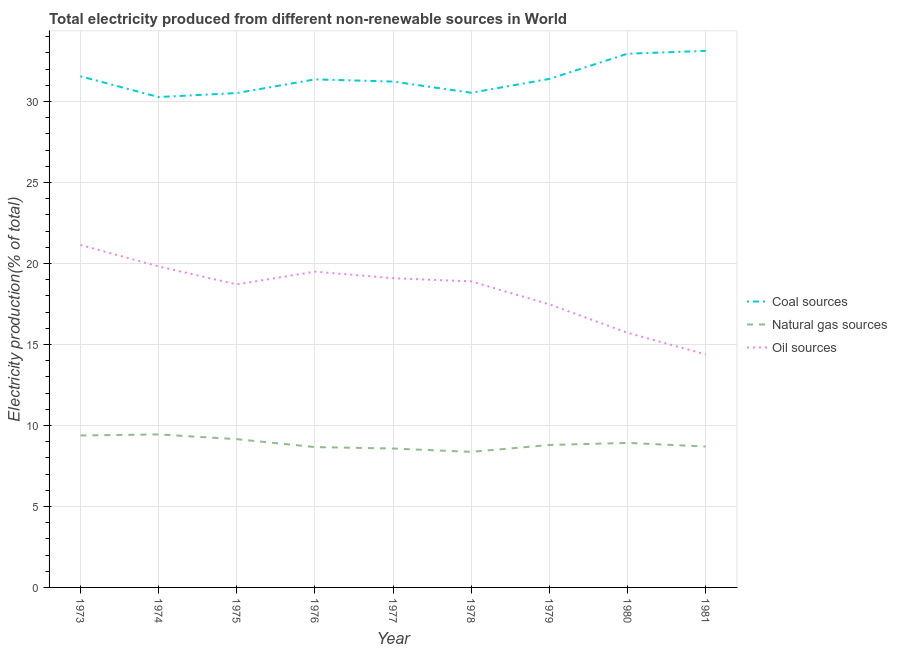How many different coloured lines are there?
Give a very brief answer. 3. Is the number of lines equal to the number of legend labels?
Offer a very short reply. Yes. What is the percentage of electricity produced by natural gas in 1980?
Provide a succinct answer. 8.92. Across all years, what is the maximum percentage of electricity produced by coal?
Give a very brief answer. 33.12. Across all years, what is the minimum percentage of electricity produced by natural gas?
Give a very brief answer. 8.37. In which year was the percentage of electricity produced by natural gas maximum?
Ensure brevity in your answer.  1974. In which year was the percentage of electricity produced by natural gas minimum?
Your answer should be compact. 1978. What is the total percentage of electricity produced by coal in the graph?
Offer a very short reply. 282.95. What is the difference between the percentage of electricity produced by oil sources in 1974 and that in 1978?
Offer a very short reply. 0.92. What is the difference between the percentage of electricity produced by coal in 1981 and the percentage of electricity produced by oil sources in 1979?
Provide a succinct answer. 15.65. What is the average percentage of electricity produced by oil sources per year?
Make the answer very short. 18.3. In the year 1980, what is the difference between the percentage of electricity produced by oil sources and percentage of electricity produced by coal?
Provide a succinct answer. -17.23. In how many years, is the percentage of electricity produced by coal greater than 30 %?
Provide a succinct answer. 9. What is the ratio of the percentage of electricity produced by coal in 1975 to that in 1977?
Your response must be concise. 0.98. Is the difference between the percentage of electricity produced by oil sources in 1979 and 1981 greater than the difference between the percentage of electricity produced by coal in 1979 and 1981?
Offer a terse response. Yes. What is the difference between the highest and the second highest percentage of electricity produced by oil sources?
Offer a very short reply. 1.33. What is the difference between the highest and the lowest percentage of electricity produced by natural gas?
Keep it short and to the point. 1.08. Does the percentage of electricity produced by natural gas monotonically increase over the years?
Provide a succinct answer. No. Is the percentage of electricity produced by coal strictly greater than the percentage of electricity produced by oil sources over the years?
Give a very brief answer. Yes. How many lines are there?
Offer a very short reply. 3. How many years are there in the graph?
Make the answer very short. 9. Are the values on the major ticks of Y-axis written in scientific E-notation?
Give a very brief answer. No. Where does the legend appear in the graph?
Offer a terse response. Center right. What is the title of the graph?
Give a very brief answer. Total electricity produced from different non-renewable sources in World. What is the label or title of the Y-axis?
Offer a terse response. Electricity production(% of total). What is the Electricity production(% of total) of Coal sources in 1973?
Make the answer very short. 31.56. What is the Electricity production(% of total) of Natural gas sources in 1973?
Make the answer very short. 9.38. What is the Electricity production(% of total) of Oil sources in 1973?
Make the answer very short. 21.15. What is the Electricity production(% of total) of Coal sources in 1974?
Give a very brief answer. 30.27. What is the Electricity production(% of total) of Natural gas sources in 1974?
Your response must be concise. 9.45. What is the Electricity production(% of total) of Oil sources in 1974?
Provide a succinct answer. 19.82. What is the Electricity production(% of total) in Coal sources in 1975?
Provide a short and direct response. 30.52. What is the Electricity production(% of total) of Natural gas sources in 1975?
Keep it short and to the point. 9.15. What is the Electricity production(% of total) of Oil sources in 1975?
Offer a terse response. 18.71. What is the Electricity production(% of total) of Coal sources in 1976?
Keep it short and to the point. 31.36. What is the Electricity production(% of total) in Natural gas sources in 1976?
Provide a succinct answer. 8.66. What is the Electricity production(% of total) of Oil sources in 1976?
Keep it short and to the point. 19.5. What is the Electricity production(% of total) of Coal sources in 1977?
Keep it short and to the point. 31.23. What is the Electricity production(% of total) of Natural gas sources in 1977?
Your response must be concise. 8.58. What is the Electricity production(% of total) in Oil sources in 1977?
Offer a very short reply. 19.09. What is the Electricity production(% of total) in Coal sources in 1978?
Your response must be concise. 30.54. What is the Electricity production(% of total) of Natural gas sources in 1978?
Offer a very short reply. 8.37. What is the Electricity production(% of total) in Oil sources in 1978?
Provide a succinct answer. 18.89. What is the Electricity production(% of total) of Coal sources in 1979?
Your answer should be compact. 31.39. What is the Electricity production(% of total) in Natural gas sources in 1979?
Provide a succinct answer. 8.79. What is the Electricity production(% of total) in Oil sources in 1979?
Offer a very short reply. 17.48. What is the Electricity production(% of total) in Coal sources in 1980?
Ensure brevity in your answer.  32.95. What is the Electricity production(% of total) of Natural gas sources in 1980?
Your response must be concise. 8.92. What is the Electricity production(% of total) of Oil sources in 1980?
Keep it short and to the point. 15.72. What is the Electricity production(% of total) in Coal sources in 1981?
Give a very brief answer. 33.12. What is the Electricity production(% of total) of Natural gas sources in 1981?
Provide a short and direct response. 8.7. What is the Electricity production(% of total) in Oil sources in 1981?
Provide a short and direct response. 14.39. Across all years, what is the maximum Electricity production(% of total) of Coal sources?
Offer a very short reply. 33.12. Across all years, what is the maximum Electricity production(% of total) in Natural gas sources?
Ensure brevity in your answer.  9.45. Across all years, what is the maximum Electricity production(% of total) of Oil sources?
Offer a very short reply. 21.15. Across all years, what is the minimum Electricity production(% of total) in Coal sources?
Keep it short and to the point. 30.27. Across all years, what is the minimum Electricity production(% of total) of Natural gas sources?
Give a very brief answer. 8.37. Across all years, what is the minimum Electricity production(% of total) in Oil sources?
Your answer should be very brief. 14.39. What is the total Electricity production(% of total) of Coal sources in the graph?
Provide a short and direct response. 282.95. What is the total Electricity production(% of total) of Natural gas sources in the graph?
Provide a short and direct response. 80. What is the total Electricity production(% of total) of Oil sources in the graph?
Provide a short and direct response. 164.73. What is the difference between the Electricity production(% of total) of Coal sources in 1973 and that in 1974?
Ensure brevity in your answer.  1.28. What is the difference between the Electricity production(% of total) in Natural gas sources in 1973 and that in 1974?
Offer a very short reply. -0.07. What is the difference between the Electricity production(% of total) of Oil sources in 1973 and that in 1974?
Keep it short and to the point. 1.33. What is the difference between the Electricity production(% of total) of Coal sources in 1973 and that in 1975?
Keep it short and to the point. 1.04. What is the difference between the Electricity production(% of total) in Natural gas sources in 1973 and that in 1975?
Offer a very short reply. 0.23. What is the difference between the Electricity production(% of total) of Oil sources in 1973 and that in 1975?
Your response must be concise. 2.44. What is the difference between the Electricity production(% of total) of Coal sources in 1973 and that in 1976?
Provide a short and direct response. 0.19. What is the difference between the Electricity production(% of total) in Natural gas sources in 1973 and that in 1976?
Offer a very short reply. 0.72. What is the difference between the Electricity production(% of total) in Oil sources in 1973 and that in 1976?
Your answer should be compact. 1.65. What is the difference between the Electricity production(% of total) of Coal sources in 1973 and that in 1977?
Your response must be concise. 0.32. What is the difference between the Electricity production(% of total) of Natural gas sources in 1973 and that in 1977?
Keep it short and to the point. 0.81. What is the difference between the Electricity production(% of total) in Oil sources in 1973 and that in 1977?
Offer a very short reply. 2.05. What is the difference between the Electricity production(% of total) of Coal sources in 1973 and that in 1978?
Provide a short and direct response. 1.02. What is the difference between the Electricity production(% of total) in Natural gas sources in 1973 and that in 1978?
Keep it short and to the point. 1.01. What is the difference between the Electricity production(% of total) of Oil sources in 1973 and that in 1978?
Provide a short and direct response. 2.25. What is the difference between the Electricity production(% of total) in Coal sources in 1973 and that in 1979?
Keep it short and to the point. 0.16. What is the difference between the Electricity production(% of total) of Natural gas sources in 1973 and that in 1979?
Your response must be concise. 0.59. What is the difference between the Electricity production(% of total) of Oil sources in 1973 and that in 1979?
Give a very brief answer. 3.67. What is the difference between the Electricity production(% of total) in Coal sources in 1973 and that in 1980?
Give a very brief answer. -1.39. What is the difference between the Electricity production(% of total) in Natural gas sources in 1973 and that in 1980?
Provide a succinct answer. 0.46. What is the difference between the Electricity production(% of total) in Oil sources in 1973 and that in 1980?
Make the answer very short. 5.42. What is the difference between the Electricity production(% of total) of Coal sources in 1973 and that in 1981?
Keep it short and to the point. -1.57. What is the difference between the Electricity production(% of total) in Natural gas sources in 1973 and that in 1981?
Your answer should be very brief. 0.68. What is the difference between the Electricity production(% of total) of Oil sources in 1973 and that in 1981?
Provide a succinct answer. 6.76. What is the difference between the Electricity production(% of total) of Coal sources in 1974 and that in 1975?
Make the answer very short. -0.25. What is the difference between the Electricity production(% of total) in Natural gas sources in 1974 and that in 1975?
Offer a very short reply. 0.29. What is the difference between the Electricity production(% of total) in Oil sources in 1974 and that in 1975?
Make the answer very short. 1.11. What is the difference between the Electricity production(% of total) of Coal sources in 1974 and that in 1976?
Keep it short and to the point. -1.09. What is the difference between the Electricity production(% of total) of Natural gas sources in 1974 and that in 1976?
Give a very brief answer. 0.78. What is the difference between the Electricity production(% of total) in Oil sources in 1974 and that in 1976?
Ensure brevity in your answer.  0.32. What is the difference between the Electricity production(% of total) in Coal sources in 1974 and that in 1977?
Offer a terse response. -0.96. What is the difference between the Electricity production(% of total) of Natural gas sources in 1974 and that in 1977?
Provide a succinct answer. 0.87. What is the difference between the Electricity production(% of total) in Oil sources in 1974 and that in 1977?
Offer a terse response. 0.73. What is the difference between the Electricity production(% of total) in Coal sources in 1974 and that in 1978?
Offer a terse response. -0.26. What is the difference between the Electricity production(% of total) of Natural gas sources in 1974 and that in 1978?
Your answer should be compact. 1.08. What is the difference between the Electricity production(% of total) in Oil sources in 1974 and that in 1978?
Keep it short and to the point. 0.92. What is the difference between the Electricity production(% of total) in Coal sources in 1974 and that in 1979?
Provide a short and direct response. -1.12. What is the difference between the Electricity production(% of total) of Natural gas sources in 1974 and that in 1979?
Your answer should be compact. 0.65. What is the difference between the Electricity production(% of total) in Oil sources in 1974 and that in 1979?
Provide a short and direct response. 2.34. What is the difference between the Electricity production(% of total) of Coal sources in 1974 and that in 1980?
Provide a succinct answer. -2.68. What is the difference between the Electricity production(% of total) in Natural gas sources in 1974 and that in 1980?
Your answer should be compact. 0.52. What is the difference between the Electricity production(% of total) in Oil sources in 1974 and that in 1980?
Provide a short and direct response. 4.1. What is the difference between the Electricity production(% of total) in Coal sources in 1974 and that in 1981?
Provide a succinct answer. -2.85. What is the difference between the Electricity production(% of total) of Natural gas sources in 1974 and that in 1981?
Your response must be concise. 0.75. What is the difference between the Electricity production(% of total) of Oil sources in 1974 and that in 1981?
Keep it short and to the point. 5.43. What is the difference between the Electricity production(% of total) in Coal sources in 1975 and that in 1976?
Offer a terse response. -0.84. What is the difference between the Electricity production(% of total) in Natural gas sources in 1975 and that in 1976?
Offer a terse response. 0.49. What is the difference between the Electricity production(% of total) of Oil sources in 1975 and that in 1976?
Ensure brevity in your answer.  -0.79. What is the difference between the Electricity production(% of total) in Coal sources in 1975 and that in 1977?
Your answer should be compact. -0.71. What is the difference between the Electricity production(% of total) of Natural gas sources in 1975 and that in 1977?
Keep it short and to the point. 0.58. What is the difference between the Electricity production(% of total) in Oil sources in 1975 and that in 1977?
Keep it short and to the point. -0.39. What is the difference between the Electricity production(% of total) of Coal sources in 1975 and that in 1978?
Ensure brevity in your answer.  -0.02. What is the difference between the Electricity production(% of total) in Natural gas sources in 1975 and that in 1978?
Your response must be concise. 0.78. What is the difference between the Electricity production(% of total) of Oil sources in 1975 and that in 1978?
Give a very brief answer. -0.19. What is the difference between the Electricity production(% of total) in Coal sources in 1975 and that in 1979?
Give a very brief answer. -0.87. What is the difference between the Electricity production(% of total) of Natural gas sources in 1975 and that in 1979?
Keep it short and to the point. 0.36. What is the difference between the Electricity production(% of total) of Oil sources in 1975 and that in 1979?
Provide a succinct answer. 1.23. What is the difference between the Electricity production(% of total) in Coal sources in 1975 and that in 1980?
Keep it short and to the point. -2.43. What is the difference between the Electricity production(% of total) in Natural gas sources in 1975 and that in 1980?
Provide a short and direct response. 0.23. What is the difference between the Electricity production(% of total) of Oil sources in 1975 and that in 1980?
Keep it short and to the point. 2.98. What is the difference between the Electricity production(% of total) in Coal sources in 1975 and that in 1981?
Make the answer very short. -2.6. What is the difference between the Electricity production(% of total) of Natural gas sources in 1975 and that in 1981?
Ensure brevity in your answer.  0.46. What is the difference between the Electricity production(% of total) of Oil sources in 1975 and that in 1981?
Your answer should be compact. 4.32. What is the difference between the Electricity production(% of total) in Coal sources in 1976 and that in 1977?
Ensure brevity in your answer.  0.13. What is the difference between the Electricity production(% of total) in Natural gas sources in 1976 and that in 1977?
Keep it short and to the point. 0.09. What is the difference between the Electricity production(% of total) of Oil sources in 1976 and that in 1977?
Make the answer very short. 0.4. What is the difference between the Electricity production(% of total) in Coal sources in 1976 and that in 1978?
Offer a very short reply. 0.83. What is the difference between the Electricity production(% of total) of Natural gas sources in 1976 and that in 1978?
Offer a very short reply. 0.3. What is the difference between the Electricity production(% of total) of Oil sources in 1976 and that in 1978?
Offer a very short reply. 0.6. What is the difference between the Electricity production(% of total) of Coal sources in 1976 and that in 1979?
Your answer should be very brief. -0.03. What is the difference between the Electricity production(% of total) of Natural gas sources in 1976 and that in 1979?
Provide a succinct answer. -0.13. What is the difference between the Electricity production(% of total) of Oil sources in 1976 and that in 1979?
Your answer should be compact. 2.02. What is the difference between the Electricity production(% of total) of Coal sources in 1976 and that in 1980?
Keep it short and to the point. -1.59. What is the difference between the Electricity production(% of total) in Natural gas sources in 1976 and that in 1980?
Keep it short and to the point. -0.26. What is the difference between the Electricity production(% of total) of Oil sources in 1976 and that in 1980?
Keep it short and to the point. 3.77. What is the difference between the Electricity production(% of total) of Coal sources in 1976 and that in 1981?
Make the answer very short. -1.76. What is the difference between the Electricity production(% of total) in Natural gas sources in 1976 and that in 1981?
Your answer should be very brief. -0.03. What is the difference between the Electricity production(% of total) of Oil sources in 1976 and that in 1981?
Ensure brevity in your answer.  5.11. What is the difference between the Electricity production(% of total) in Coal sources in 1977 and that in 1978?
Give a very brief answer. 0.69. What is the difference between the Electricity production(% of total) of Natural gas sources in 1977 and that in 1978?
Offer a terse response. 0.21. What is the difference between the Electricity production(% of total) in Oil sources in 1977 and that in 1978?
Provide a succinct answer. 0.2. What is the difference between the Electricity production(% of total) in Coal sources in 1977 and that in 1979?
Your response must be concise. -0.16. What is the difference between the Electricity production(% of total) in Natural gas sources in 1977 and that in 1979?
Provide a short and direct response. -0.22. What is the difference between the Electricity production(% of total) of Oil sources in 1977 and that in 1979?
Your answer should be very brief. 1.61. What is the difference between the Electricity production(% of total) of Coal sources in 1977 and that in 1980?
Offer a terse response. -1.72. What is the difference between the Electricity production(% of total) of Natural gas sources in 1977 and that in 1980?
Provide a short and direct response. -0.35. What is the difference between the Electricity production(% of total) in Oil sources in 1977 and that in 1980?
Keep it short and to the point. 3.37. What is the difference between the Electricity production(% of total) of Coal sources in 1977 and that in 1981?
Offer a terse response. -1.89. What is the difference between the Electricity production(% of total) in Natural gas sources in 1977 and that in 1981?
Keep it short and to the point. -0.12. What is the difference between the Electricity production(% of total) of Oil sources in 1977 and that in 1981?
Offer a terse response. 4.7. What is the difference between the Electricity production(% of total) in Coal sources in 1978 and that in 1979?
Ensure brevity in your answer.  -0.86. What is the difference between the Electricity production(% of total) of Natural gas sources in 1978 and that in 1979?
Provide a succinct answer. -0.42. What is the difference between the Electricity production(% of total) of Oil sources in 1978 and that in 1979?
Ensure brevity in your answer.  1.42. What is the difference between the Electricity production(% of total) of Coal sources in 1978 and that in 1980?
Your response must be concise. -2.41. What is the difference between the Electricity production(% of total) in Natural gas sources in 1978 and that in 1980?
Provide a short and direct response. -0.55. What is the difference between the Electricity production(% of total) of Oil sources in 1978 and that in 1980?
Give a very brief answer. 3.17. What is the difference between the Electricity production(% of total) in Coal sources in 1978 and that in 1981?
Your answer should be compact. -2.59. What is the difference between the Electricity production(% of total) of Natural gas sources in 1978 and that in 1981?
Ensure brevity in your answer.  -0.33. What is the difference between the Electricity production(% of total) of Oil sources in 1978 and that in 1981?
Provide a succinct answer. 4.51. What is the difference between the Electricity production(% of total) of Coal sources in 1979 and that in 1980?
Give a very brief answer. -1.56. What is the difference between the Electricity production(% of total) of Natural gas sources in 1979 and that in 1980?
Your response must be concise. -0.13. What is the difference between the Electricity production(% of total) in Oil sources in 1979 and that in 1980?
Offer a very short reply. 1.76. What is the difference between the Electricity production(% of total) of Coal sources in 1979 and that in 1981?
Provide a short and direct response. -1.73. What is the difference between the Electricity production(% of total) in Natural gas sources in 1979 and that in 1981?
Provide a succinct answer. 0.1. What is the difference between the Electricity production(% of total) in Oil sources in 1979 and that in 1981?
Your response must be concise. 3.09. What is the difference between the Electricity production(% of total) of Coal sources in 1980 and that in 1981?
Provide a succinct answer. -0.17. What is the difference between the Electricity production(% of total) in Natural gas sources in 1980 and that in 1981?
Give a very brief answer. 0.22. What is the difference between the Electricity production(% of total) of Oil sources in 1980 and that in 1981?
Give a very brief answer. 1.33. What is the difference between the Electricity production(% of total) in Coal sources in 1973 and the Electricity production(% of total) in Natural gas sources in 1974?
Make the answer very short. 22.11. What is the difference between the Electricity production(% of total) in Coal sources in 1973 and the Electricity production(% of total) in Oil sources in 1974?
Your answer should be compact. 11.74. What is the difference between the Electricity production(% of total) of Natural gas sources in 1973 and the Electricity production(% of total) of Oil sources in 1974?
Offer a terse response. -10.44. What is the difference between the Electricity production(% of total) in Coal sources in 1973 and the Electricity production(% of total) in Natural gas sources in 1975?
Your answer should be very brief. 22.4. What is the difference between the Electricity production(% of total) of Coal sources in 1973 and the Electricity production(% of total) of Oil sources in 1975?
Ensure brevity in your answer.  12.85. What is the difference between the Electricity production(% of total) in Natural gas sources in 1973 and the Electricity production(% of total) in Oil sources in 1975?
Give a very brief answer. -9.32. What is the difference between the Electricity production(% of total) in Coal sources in 1973 and the Electricity production(% of total) in Natural gas sources in 1976?
Your answer should be compact. 22.89. What is the difference between the Electricity production(% of total) of Coal sources in 1973 and the Electricity production(% of total) of Oil sources in 1976?
Offer a very short reply. 12.06. What is the difference between the Electricity production(% of total) of Natural gas sources in 1973 and the Electricity production(% of total) of Oil sources in 1976?
Your answer should be compact. -10.11. What is the difference between the Electricity production(% of total) in Coal sources in 1973 and the Electricity production(% of total) in Natural gas sources in 1977?
Keep it short and to the point. 22.98. What is the difference between the Electricity production(% of total) of Coal sources in 1973 and the Electricity production(% of total) of Oil sources in 1977?
Ensure brevity in your answer.  12.46. What is the difference between the Electricity production(% of total) in Natural gas sources in 1973 and the Electricity production(% of total) in Oil sources in 1977?
Give a very brief answer. -9.71. What is the difference between the Electricity production(% of total) of Coal sources in 1973 and the Electricity production(% of total) of Natural gas sources in 1978?
Provide a short and direct response. 23.19. What is the difference between the Electricity production(% of total) of Coal sources in 1973 and the Electricity production(% of total) of Oil sources in 1978?
Provide a short and direct response. 12.66. What is the difference between the Electricity production(% of total) in Natural gas sources in 1973 and the Electricity production(% of total) in Oil sources in 1978?
Offer a terse response. -9.51. What is the difference between the Electricity production(% of total) of Coal sources in 1973 and the Electricity production(% of total) of Natural gas sources in 1979?
Keep it short and to the point. 22.76. What is the difference between the Electricity production(% of total) of Coal sources in 1973 and the Electricity production(% of total) of Oil sources in 1979?
Your answer should be very brief. 14.08. What is the difference between the Electricity production(% of total) in Natural gas sources in 1973 and the Electricity production(% of total) in Oil sources in 1979?
Provide a short and direct response. -8.1. What is the difference between the Electricity production(% of total) of Coal sources in 1973 and the Electricity production(% of total) of Natural gas sources in 1980?
Provide a succinct answer. 22.63. What is the difference between the Electricity production(% of total) in Coal sources in 1973 and the Electricity production(% of total) in Oil sources in 1980?
Give a very brief answer. 15.83. What is the difference between the Electricity production(% of total) of Natural gas sources in 1973 and the Electricity production(% of total) of Oil sources in 1980?
Provide a short and direct response. -6.34. What is the difference between the Electricity production(% of total) in Coal sources in 1973 and the Electricity production(% of total) in Natural gas sources in 1981?
Make the answer very short. 22.86. What is the difference between the Electricity production(% of total) of Coal sources in 1973 and the Electricity production(% of total) of Oil sources in 1981?
Give a very brief answer. 17.17. What is the difference between the Electricity production(% of total) in Natural gas sources in 1973 and the Electricity production(% of total) in Oil sources in 1981?
Make the answer very short. -5.01. What is the difference between the Electricity production(% of total) of Coal sources in 1974 and the Electricity production(% of total) of Natural gas sources in 1975?
Ensure brevity in your answer.  21.12. What is the difference between the Electricity production(% of total) in Coal sources in 1974 and the Electricity production(% of total) in Oil sources in 1975?
Provide a succinct answer. 11.57. What is the difference between the Electricity production(% of total) in Natural gas sources in 1974 and the Electricity production(% of total) in Oil sources in 1975?
Provide a succinct answer. -9.26. What is the difference between the Electricity production(% of total) of Coal sources in 1974 and the Electricity production(% of total) of Natural gas sources in 1976?
Your answer should be compact. 21.61. What is the difference between the Electricity production(% of total) of Coal sources in 1974 and the Electricity production(% of total) of Oil sources in 1976?
Keep it short and to the point. 10.78. What is the difference between the Electricity production(% of total) in Natural gas sources in 1974 and the Electricity production(% of total) in Oil sources in 1976?
Provide a short and direct response. -10.05. What is the difference between the Electricity production(% of total) of Coal sources in 1974 and the Electricity production(% of total) of Natural gas sources in 1977?
Make the answer very short. 21.7. What is the difference between the Electricity production(% of total) in Coal sources in 1974 and the Electricity production(% of total) in Oil sources in 1977?
Provide a succinct answer. 11.18. What is the difference between the Electricity production(% of total) of Natural gas sources in 1974 and the Electricity production(% of total) of Oil sources in 1977?
Your answer should be very brief. -9.64. What is the difference between the Electricity production(% of total) in Coal sources in 1974 and the Electricity production(% of total) in Natural gas sources in 1978?
Keep it short and to the point. 21.91. What is the difference between the Electricity production(% of total) in Coal sources in 1974 and the Electricity production(% of total) in Oil sources in 1978?
Provide a short and direct response. 11.38. What is the difference between the Electricity production(% of total) in Natural gas sources in 1974 and the Electricity production(% of total) in Oil sources in 1978?
Your answer should be compact. -9.45. What is the difference between the Electricity production(% of total) in Coal sources in 1974 and the Electricity production(% of total) in Natural gas sources in 1979?
Make the answer very short. 21.48. What is the difference between the Electricity production(% of total) in Coal sources in 1974 and the Electricity production(% of total) in Oil sources in 1979?
Offer a terse response. 12.8. What is the difference between the Electricity production(% of total) in Natural gas sources in 1974 and the Electricity production(% of total) in Oil sources in 1979?
Provide a succinct answer. -8.03. What is the difference between the Electricity production(% of total) of Coal sources in 1974 and the Electricity production(% of total) of Natural gas sources in 1980?
Ensure brevity in your answer.  21.35. What is the difference between the Electricity production(% of total) in Coal sources in 1974 and the Electricity production(% of total) in Oil sources in 1980?
Offer a very short reply. 14.55. What is the difference between the Electricity production(% of total) of Natural gas sources in 1974 and the Electricity production(% of total) of Oil sources in 1980?
Give a very brief answer. -6.27. What is the difference between the Electricity production(% of total) in Coal sources in 1974 and the Electricity production(% of total) in Natural gas sources in 1981?
Provide a short and direct response. 21.58. What is the difference between the Electricity production(% of total) of Coal sources in 1974 and the Electricity production(% of total) of Oil sources in 1981?
Your response must be concise. 15.89. What is the difference between the Electricity production(% of total) in Natural gas sources in 1974 and the Electricity production(% of total) in Oil sources in 1981?
Keep it short and to the point. -4.94. What is the difference between the Electricity production(% of total) of Coal sources in 1975 and the Electricity production(% of total) of Natural gas sources in 1976?
Provide a succinct answer. 21.86. What is the difference between the Electricity production(% of total) in Coal sources in 1975 and the Electricity production(% of total) in Oil sources in 1976?
Offer a terse response. 11.02. What is the difference between the Electricity production(% of total) of Natural gas sources in 1975 and the Electricity production(% of total) of Oil sources in 1976?
Your answer should be very brief. -10.34. What is the difference between the Electricity production(% of total) in Coal sources in 1975 and the Electricity production(% of total) in Natural gas sources in 1977?
Your answer should be very brief. 21.94. What is the difference between the Electricity production(% of total) in Coal sources in 1975 and the Electricity production(% of total) in Oil sources in 1977?
Your answer should be compact. 11.43. What is the difference between the Electricity production(% of total) in Natural gas sources in 1975 and the Electricity production(% of total) in Oil sources in 1977?
Provide a succinct answer. -9.94. What is the difference between the Electricity production(% of total) in Coal sources in 1975 and the Electricity production(% of total) in Natural gas sources in 1978?
Ensure brevity in your answer.  22.15. What is the difference between the Electricity production(% of total) of Coal sources in 1975 and the Electricity production(% of total) of Oil sources in 1978?
Make the answer very short. 11.63. What is the difference between the Electricity production(% of total) of Natural gas sources in 1975 and the Electricity production(% of total) of Oil sources in 1978?
Your answer should be compact. -9.74. What is the difference between the Electricity production(% of total) in Coal sources in 1975 and the Electricity production(% of total) in Natural gas sources in 1979?
Your response must be concise. 21.73. What is the difference between the Electricity production(% of total) in Coal sources in 1975 and the Electricity production(% of total) in Oil sources in 1979?
Offer a very short reply. 13.04. What is the difference between the Electricity production(% of total) in Natural gas sources in 1975 and the Electricity production(% of total) in Oil sources in 1979?
Provide a succinct answer. -8.32. What is the difference between the Electricity production(% of total) in Coal sources in 1975 and the Electricity production(% of total) in Natural gas sources in 1980?
Keep it short and to the point. 21.6. What is the difference between the Electricity production(% of total) of Coal sources in 1975 and the Electricity production(% of total) of Oil sources in 1980?
Offer a terse response. 14.8. What is the difference between the Electricity production(% of total) of Natural gas sources in 1975 and the Electricity production(% of total) of Oil sources in 1980?
Offer a terse response. -6.57. What is the difference between the Electricity production(% of total) of Coal sources in 1975 and the Electricity production(% of total) of Natural gas sources in 1981?
Give a very brief answer. 21.82. What is the difference between the Electricity production(% of total) in Coal sources in 1975 and the Electricity production(% of total) in Oil sources in 1981?
Your answer should be very brief. 16.13. What is the difference between the Electricity production(% of total) in Natural gas sources in 1975 and the Electricity production(% of total) in Oil sources in 1981?
Give a very brief answer. -5.23. What is the difference between the Electricity production(% of total) in Coal sources in 1976 and the Electricity production(% of total) in Natural gas sources in 1977?
Give a very brief answer. 22.79. What is the difference between the Electricity production(% of total) of Coal sources in 1976 and the Electricity production(% of total) of Oil sources in 1977?
Keep it short and to the point. 12.27. What is the difference between the Electricity production(% of total) of Natural gas sources in 1976 and the Electricity production(% of total) of Oil sources in 1977?
Your answer should be compact. -10.43. What is the difference between the Electricity production(% of total) of Coal sources in 1976 and the Electricity production(% of total) of Natural gas sources in 1978?
Keep it short and to the point. 23. What is the difference between the Electricity production(% of total) of Coal sources in 1976 and the Electricity production(% of total) of Oil sources in 1978?
Give a very brief answer. 12.47. What is the difference between the Electricity production(% of total) of Natural gas sources in 1976 and the Electricity production(% of total) of Oil sources in 1978?
Your response must be concise. -10.23. What is the difference between the Electricity production(% of total) in Coal sources in 1976 and the Electricity production(% of total) in Natural gas sources in 1979?
Your answer should be very brief. 22.57. What is the difference between the Electricity production(% of total) of Coal sources in 1976 and the Electricity production(% of total) of Oil sources in 1979?
Offer a very short reply. 13.89. What is the difference between the Electricity production(% of total) of Natural gas sources in 1976 and the Electricity production(% of total) of Oil sources in 1979?
Make the answer very short. -8.81. What is the difference between the Electricity production(% of total) in Coal sources in 1976 and the Electricity production(% of total) in Natural gas sources in 1980?
Your response must be concise. 22.44. What is the difference between the Electricity production(% of total) in Coal sources in 1976 and the Electricity production(% of total) in Oil sources in 1980?
Provide a short and direct response. 15.64. What is the difference between the Electricity production(% of total) in Natural gas sources in 1976 and the Electricity production(% of total) in Oil sources in 1980?
Give a very brief answer. -7.06. What is the difference between the Electricity production(% of total) in Coal sources in 1976 and the Electricity production(% of total) in Natural gas sources in 1981?
Give a very brief answer. 22.67. What is the difference between the Electricity production(% of total) of Coal sources in 1976 and the Electricity production(% of total) of Oil sources in 1981?
Provide a short and direct response. 16.98. What is the difference between the Electricity production(% of total) in Natural gas sources in 1976 and the Electricity production(% of total) in Oil sources in 1981?
Provide a short and direct response. -5.72. What is the difference between the Electricity production(% of total) in Coal sources in 1977 and the Electricity production(% of total) in Natural gas sources in 1978?
Offer a terse response. 22.86. What is the difference between the Electricity production(% of total) in Coal sources in 1977 and the Electricity production(% of total) in Oil sources in 1978?
Make the answer very short. 12.34. What is the difference between the Electricity production(% of total) in Natural gas sources in 1977 and the Electricity production(% of total) in Oil sources in 1978?
Provide a succinct answer. -10.32. What is the difference between the Electricity production(% of total) in Coal sources in 1977 and the Electricity production(% of total) in Natural gas sources in 1979?
Give a very brief answer. 22.44. What is the difference between the Electricity production(% of total) of Coal sources in 1977 and the Electricity production(% of total) of Oil sources in 1979?
Your answer should be compact. 13.75. What is the difference between the Electricity production(% of total) in Natural gas sources in 1977 and the Electricity production(% of total) in Oil sources in 1979?
Ensure brevity in your answer.  -8.9. What is the difference between the Electricity production(% of total) of Coal sources in 1977 and the Electricity production(% of total) of Natural gas sources in 1980?
Offer a very short reply. 22.31. What is the difference between the Electricity production(% of total) of Coal sources in 1977 and the Electricity production(% of total) of Oil sources in 1980?
Provide a short and direct response. 15.51. What is the difference between the Electricity production(% of total) in Natural gas sources in 1977 and the Electricity production(% of total) in Oil sources in 1980?
Give a very brief answer. -7.15. What is the difference between the Electricity production(% of total) of Coal sources in 1977 and the Electricity production(% of total) of Natural gas sources in 1981?
Keep it short and to the point. 22.53. What is the difference between the Electricity production(% of total) in Coal sources in 1977 and the Electricity production(% of total) in Oil sources in 1981?
Your answer should be very brief. 16.84. What is the difference between the Electricity production(% of total) of Natural gas sources in 1977 and the Electricity production(% of total) of Oil sources in 1981?
Provide a short and direct response. -5.81. What is the difference between the Electricity production(% of total) of Coal sources in 1978 and the Electricity production(% of total) of Natural gas sources in 1979?
Make the answer very short. 21.75. What is the difference between the Electricity production(% of total) of Coal sources in 1978 and the Electricity production(% of total) of Oil sources in 1979?
Keep it short and to the point. 13.06. What is the difference between the Electricity production(% of total) of Natural gas sources in 1978 and the Electricity production(% of total) of Oil sources in 1979?
Make the answer very short. -9.11. What is the difference between the Electricity production(% of total) in Coal sources in 1978 and the Electricity production(% of total) in Natural gas sources in 1980?
Your answer should be very brief. 21.62. What is the difference between the Electricity production(% of total) in Coal sources in 1978 and the Electricity production(% of total) in Oil sources in 1980?
Provide a short and direct response. 14.82. What is the difference between the Electricity production(% of total) in Natural gas sources in 1978 and the Electricity production(% of total) in Oil sources in 1980?
Ensure brevity in your answer.  -7.35. What is the difference between the Electricity production(% of total) of Coal sources in 1978 and the Electricity production(% of total) of Natural gas sources in 1981?
Your response must be concise. 21.84. What is the difference between the Electricity production(% of total) in Coal sources in 1978 and the Electricity production(% of total) in Oil sources in 1981?
Keep it short and to the point. 16.15. What is the difference between the Electricity production(% of total) in Natural gas sources in 1978 and the Electricity production(% of total) in Oil sources in 1981?
Provide a succinct answer. -6.02. What is the difference between the Electricity production(% of total) of Coal sources in 1979 and the Electricity production(% of total) of Natural gas sources in 1980?
Make the answer very short. 22.47. What is the difference between the Electricity production(% of total) of Coal sources in 1979 and the Electricity production(% of total) of Oil sources in 1980?
Give a very brief answer. 15.67. What is the difference between the Electricity production(% of total) in Natural gas sources in 1979 and the Electricity production(% of total) in Oil sources in 1980?
Offer a very short reply. -6.93. What is the difference between the Electricity production(% of total) in Coal sources in 1979 and the Electricity production(% of total) in Natural gas sources in 1981?
Provide a short and direct response. 22.7. What is the difference between the Electricity production(% of total) of Coal sources in 1979 and the Electricity production(% of total) of Oil sources in 1981?
Give a very brief answer. 17.01. What is the difference between the Electricity production(% of total) of Natural gas sources in 1979 and the Electricity production(% of total) of Oil sources in 1981?
Offer a terse response. -5.59. What is the difference between the Electricity production(% of total) in Coal sources in 1980 and the Electricity production(% of total) in Natural gas sources in 1981?
Make the answer very short. 24.25. What is the difference between the Electricity production(% of total) of Coal sources in 1980 and the Electricity production(% of total) of Oil sources in 1981?
Ensure brevity in your answer.  18.56. What is the difference between the Electricity production(% of total) in Natural gas sources in 1980 and the Electricity production(% of total) in Oil sources in 1981?
Ensure brevity in your answer.  -5.46. What is the average Electricity production(% of total) of Coal sources per year?
Give a very brief answer. 31.44. What is the average Electricity production(% of total) of Natural gas sources per year?
Keep it short and to the point. 8.89. What is the average Electricity production(% of total) in Oil sources per year?
Your response must be concise. 18.3. In the year 1973, what is the difference between the Electricity production(% of total) in Coal sources and Electricity production(% of total) in Natural gas sources?
Ensure brevity in your answer.  22.17. In the year 1973, what is the difference between the Electricity production(% of total) in Coal sources and Electricity production(% of total) in Oil sources?
Ensure brevity in your answer.  10.41. In the year 1973, what is the difference between the Electricity production(% of total) in Natural gas sources and Electricity production(% of total) in Oil sources?
Make the answer very short. -11.76. In the year 1974, what is the difference between the Electricity production(% of total) in Coal sources and Electricity production(% of total) in Natural gas sources?
Provide a succinct answer. 20.83. In the year 1974, what is the difference between the Electricity production(% of total) of Coal sources and Electricity production(% of total) of Oil sources?
Your answer should be very brief. 10.46. In the year 1974, what is the difference between the Electricity production(% of total) of Natural gas sources and Electricity production(% of total) of Oil sources?
Make the answer very short. -10.37. In the year 1975, what is the difference between the Electricity production(% of total) of Coal sources and Electricity production(% of total) of Natural gas sources?
Your response must be concise. 21.37. In the year 1975, what is the difference between the Electricity production(% of total) of Coal sources and Electricity production(% of total) of Oil sources?
Give a very brief answer. 11.81. In the year 1975, what is the difference between the Electricity production(% of total) in Natural gas sources and Electricity production(% of total) in Oil sources?
Your answer should be very brief. -9.55. In the year 1976, what is the difference between the Electricity production(% of total) of Coal sources and Electricity production(% of total) of Natural gas sources?
Ensure brevity in your answer.  22.7. In the year 1976, what is the difference between the Electricity production(% of total) in Coal sources and Electricity production(% of total) in Oil sources?
Offer a very short reply. 11.87. In the year 1976, what is the difference between the Electricity production(% of total) in Natural gas sources and Electricity production(% of total) in Oil sources?
Ensure brevity in your answer.  -10.83. In the year 1977, what is the difference between the Electricity production(% of total) in Coal sources and Electricity production(% of total) in Natural gas sources?
Ensure brevity in your answer.  22.66. In the year 1977, what is the difference between the Electricity production(% of total) in Coal sources and Electricity production(% of total) in Oil sources?
Provide a short and direct response. 12.14. In the year 1977, what is the difference between the Electricity production(% of total) in Natural gas sources and Electricity production(% of total) in Oil sources?
Give a very brief answer. -10.52. In the year 1978, what is the difference between the Electricity production(% of total) in Coal sources and Electricity production(% of total) in Natural gas sources?
Your response must be concise. 22.17. In the year 1978, what is the difference between the Electricity production(% of total) in Coal sources and Electricity production(% of total) in Oil sources?
Offer a very short reply. 11.64. In the year 1978, what is the difference between the Electricity production(% of total) in Natural gas sources and Electricity production(% of total) in Oil sources?
Offer a very short reply. -10.52. In the year 1979, what is the difference between the Electricity production(% of total) in Coal sources and Electricity production(% of total) in Natural gas sources?
Your answer should be compact. 22.6. In the year 1979, what is the difference between the Electricity production(% of total) in Coal sources and Electricity production(% of total) in Oil sources?
Offer a very short reply. 13.92. In the year 1979, what is the difference between the Electricity production(% of total) in Natural gas sources and Electricity production(% of total) in Oil sources?
Keep it short and to the point. -8.68. In the year 1980, what is the difference between the Electricity production(% of total) in Coal sources and Electricity production(% of total) in Natural gas sources?
Your response must be concise. 24.03. In the year 1980, what is the difference between the Electricity production(% of total) in Coal sources and Electricity production(% of total) in Oil sources?
Keep it short and to the point. 17.23. In the year 1980, what is the difference between the Electricity production(% of total) in Natural gas sources and Electricity production(% of total) in Oil sources?
Your response must be concise. -6.8. In the year 1981, what is the difference between the Electricity production(% of total) in Coal sources and Electricity production(% of total) in Natural gas sources?
Provide a short and direct response. 24.43. In the year 1981, what is the difference between the Electricity production(% of total) of Coal sources and Electricity production(% of total) of Oil sources?
Ensure brevity in your answer.  18.74. In the year 1981, what is the difference between the Electricity production(% of total) of Natural gas sources and Electricity production(% of total) of Oil sources?
Your response must be concise. -5.69. What is the ratio of the Electricity production(% of total) in Coal sources in 1973 to that in 1974?
Make the answer very short. 1.04. What is the ratio of the Electricity production(% of total) of Oil sources in 1973 to that in 1974?
Provide a short and direct response. 1.07. What is the ratio of the Electricity production(% of total) of Coal sources in 1973 to that in 1975?
Provide a short and direct response. 1.03. What is the ratio of the Electricity production(% of total) of Natural gas sources in 1973 to that in 1975?
Provide a short and direct response. 1.02. What is the ratio of the Electricity production(% of total) in Oil sources in 1973 to that in 1975?
Your answer should be very brief. 1.13. What is the ratio of the Electricity production(% of total) of Coal sources in 1973 to that in 1976?
Make the answer very short. 1.01. What is the ratio of the Electricity production(% of total) of Natural gas sources in 1973 to that in 1976?
Your answer should be very brief. 1.08. What is the ratio of the Electricity production(% of total) in Oil sources in 1973 to that in 1976?
Offer a very short reply. 1.08. What is the ratio of the Electricity production(% of total) in Coal sources in 1973 to that in 1977?
Offer a terse response. 1.01. What is the ratio of the Electricity production(% of total) of Natural gas sources in 1973 to that in 1977?
Your answer should be compact. 1.09. What is the ratio of the Electricity production(% of total) of Oil sources in 1973 to that in 1977?
Keep it short and to the point. 1.11. What is the ratio of the Electricity production(% of total) in Natural gas sources in 1973 to that in 1978?
Your answer should be very brief. 1.12. What is the ratio of the Electricity production(% of total) in Oil sources in 1973 to that in 1978?
Your answer should be very brief. 1.12. What is the ratio of the Electricity production(% of total) of Natural gas sources in 1973 to that in 1979?
Keep it short and to the point. 1.07. What is the ratio of the Electricity production(% of total) in Oil sources in 1973 to that in 1979?
Provide a succinct answer. 1.21. What is the ratio of the Electricity production(% of total) of Coal sources in 1973 to that in 1980?
Provide a succinct answer. 0.96. What is the ratio of the Electricity production(% of total) in Natural gas sources in 1973 to that in 1980?
Ensure brevity in your answer.  1.05. What is the ratio of the Electricity production(% of total) of Oil sources in 1973 to that in 1980?
Offer a very short reply. 1.34. What is the ratio of the Electricity production(% of total) of Coal sources in 1973 to that in 1981?
Ensure brevity in your answer.  0.95. What is the ratio of the Electricity production(% of total) in Natural gas sources in 1973 to that in 1981?
Make the answer very short. 1.08. What is the ratio of the Electricity production(% of total) of Oil sources in 1973 to that in 1981?
Your answer should be compact. 1.47. What is the ratio of the Electricity production(% of total) of Natural gas sources in 1974 to that in 1975?
Provide a succinct answer. 1.03. What is the ratio of the Electricity production(% of total) of Oil sources in 1974 to that in 1975?
Your answer should be compact. 1.06. What is the ratio of the Electricity production(% of total) of Coal sources in 1974 to that in 1976?
Ensure brevity in your answer.  0.97. What is the ratio of the Electricity production(% of total) in Natural gas sources in 1974 to that in 1976?
Make the answer very short. 1.09. What is the ratio of the Electricity production(% of total) of Oil sources in 1974 to that in 1976?
Provide a succinct answer. 1.02. What is the ratio of the Electricity production(% of total) in Coal sources in 1974 to that in 1977?
Offer a very short reply. 0.97. What is the ratio of the Electricity production(% of total) in Natural gas sources in 1974 to that in 1977?
Provide a short and direct response. 1.1. What is the ratio of the Electricity production(% of total) of Oil sources in 1974 to that in 1977?
Your answer should be compact. 1.04. What is the ratio of the Electricity production(% of total) in Natural gas sources in 1974 to that in 1978?
Your answer should be very brief. 1.13. What is the ratio of the Electricity production(% of total) of Oil sources in 1974 to that in 1978?
Give a very brief answer. 1.05. What is the ratio of the Electricity production(% of total) of Coal sources in 1974 to that in 1979?
Ensure brevity in your answer.  0.96. What is the ratio of the Electricity production(% of total) in Natural gas sources in 1974 to that in 1979?
Make the answer very short. 1.07. What is the ratio of the Electricity production(% of total) in Oil sources in 1974 to that in 1979?
Give a very brief answer. 1.13. What is the ratio of the Electricity production(% of total) of Coal sources in 1974 to that in 1980?
Your answer should be very brief. 0.92. What is the ratio of the Electricity production(% of total) of Natural gas sources in 1974 to that in 1980?
Offer a very short reply. 1.06. What is the ratio of the Electricity production(% of total) of Oil sources in 1974 to that in 1980?
Your answer should be very brief. 1.26. What is the ratio of the Electricity production(% of total) in Coal sources in 1974 to that in 1981?
Your response must be concise. 0.91. What is the ratio of the Electricity production(% of total) in Natural gas sources in 1974 to that in 1981?
Offer a terse response. 1.09. What is the ratio of the Electricity production(% of total) of Oil sources in 1974 to that in 1981?
Keep it short and to the point. 1.38. What is the ratio of the Electricity production(% of total) in Coal sources in 1975 to that in 1976?
Keep it short and to the point. 0.97. What is the ratio of the Electricity production(% of total) of Natural gas sources in 1975 to that in 1976?
Your response must be concise. 1.06. What is the ratio of the Electricity production(% of total) in Oil sources in 1975 to that in 1976?
Ensure brevity in your answer.  0.96. What is the ratio of the Electricity production(% of total) of Coal sources in 1975 to that in 1977?
Your answer should be very brief. 0.98. What is the ratio of the Electricity production(% of total) of Natural gas sources in 1975 to that in 1977?
Make the answer very short. 1.07. What is the ratio of the Electricity production(% of total) in Oil sources in 1975 to that in 1977?
Ensure brevity in your answer.  0.98. What is the ratio of the Electricity production(% of total) of Coal sources in 1975 to that in 1978?
Ensure brevity in your answer.  1. What is the ratio of the Electricity production(% of total) in Natural gas sources in 1975 to that in 1978?
Keep it short and to the point. 1.09. What is the ratio of the Electricity production(% of total) in Oil sources in 1975 to that in 1978?
Offer a very short reply. 0.99. What is the ratio of the Electricity production(% of total) of Coal sources in 1975 to that in 1979?
Your answer should be very brief. 0.97. What is the ratio of the Electricity production(% of total) in Natural gas sources in 1975 to that in 1979?
Offer a very short reply. 1.04. What is the ratio of the Electricity production(% of total) in Oil sources in 1975 to that in 1979?
Offer a terse response. 1.07. What is the ratio of the Electricity production(% of total) in Coal sources in 1975 to that in 1980?
Provide a short and direct response. 0.93. What is the ratio of the Electricity production(% of total) in Natural gas sources in 1975 to that in 1980?
Offer a very short reply. 1.03. What is the ratio of the Electricity production(% of total) of Oil sources in 1975 to that in 1980?
Ensure brevity in your answer.  1.19. What is the ratio of the Electricity production(% of total) of Coal sources in 1975 to that in 1981?
Ensure brevity in your answer.  0.92. What is the ratio of the Electricity production(% of total) in Natural gas sources in 1975 to that in 1981?
Offer a very short reply. 1.05. What is the ratio of the Electricity production(% of total) of Oil sources in 1975 to that in 1981?
Provide a short and direct response. 1.3. What is the ratio of the Electricity production(% of total) of Coal sources in 1976 to that in 1977?
Keep it short and to the point. 1. What is the ratio of the Electricity production(% of total) of Natural gas sources in 1976 to that in 1977?
Make the answer very short. 1.01. What is the ratio of the Electricity production(% of total) of Oil sources in 1976 to that in 1977?
Make the answer very short. 1.02. What is the ratio of the Electricity production(% of total) in Coal sources in 1976 to that in 1978?
Provide a succinct answer. 1.03. What is the ratio of the Electricity production(% of total) of Natural gas sources in 1976 to that in 1978?
Give a very brief answer. 1.04. What is the ratio of the Electricity production(% of total) in Oil sources in 1976 to that in 1978?
Your answer should be compact. 1.03. What is the ratio of the Electricity production(% of total) in Coal sources in 1976 to that in 1979?
Provide a succinct answer. 1. What is the ratio of the Electricity production(% of total) of Natural gas sources in 1976 to that in 1979?
Provide a short and direct response. 0.99. What is the ratio of the Electricity production(% of total) of Oil sources in 1976 to that in 1979?
Keep it short and to the point. 1.12. What is the ratio of the Electricity production(% of total) of Coal sources in 1976 to that in 1980?
Keep it short and to the point. 0.95. What is the ratio of the Electricity production(% of total) in Natural gas sources in 1976 to that in 1980?
Make the answer very short. 0.97. What is the ratio of the Electricity production(% of total) in Oil sources in 1976 to that in 1980?
Offer a very short reply. 1.24. What is the ratio of the Electricity production(% of total) of Coal sources in 1976 to that in 1981?
Your answer should be compact. 0.95. What is the ratio of the Electricity production(% of total) of Natural gas sources in 1976 to that in 1981?
Your response must be concise. 1. What is the ratio of the Electricity production(% of total) in Oil sources in 1976 to that in 1981?
Give a very brief answer. 1.36. What is the ratio of the Electricity production(% of total) of Coal sources in 1977 to that in 1978?
Provide a succinct answer. 1.02. What is the ratio of the Electricity production(% of total) in Natural gas sources in 1977 to that in 1978?
Offer a terse response. 1.02. What is the ratio of the Electricity production(% of total) of Oil sources in 1977 to that in 1978?
Ensure brevity in your answer.  1.01. What is the ratio of the Electricity production(% of total) in Coal sources in 1977 to that in 1979?
Provide a succinct answer. 0.99. What is the ratio of the Electricity production(% of total) of Natural gas sources in 1977 to that in 1979?
Your answer should be compact. 0.98. What is the ratio of the Electricity production(% of total) of Oil sources in 1977 to that in 1979?
Provide a short and direct response. 1.09. What is the ratio of the Electricity production(% of total) in Coal sources in 1977 to that in 1980?
Ensure brevity in your answer.  0.95. What is the ratio of the Electricity production(% of total) in Natural gas sources in 1977 to that in 1980?
Give a very brief answer. 0.96. What is the ratio of the Electricity production(% of total) in Oil sources in 1977 to that in 1980?
Ensure brevity in your answer.  1.21. What is the ratio of the Electricity production(% of total) in Coal sources in 1977 to that in 1981?
Offer a terse response. 0.94. What is the ratio of the Electricity production(% of total) of Natural gas sources in 1977 to that in 1981?
Ensure brevity in your answer.  0.99. What is the ratio of the Electricity production(% of total) in Oil sources in 1977 to that in 1981?
Give a very brief answer. 1.33. What is the ratio of the Electricity production(% of total) in Coal sources in 1978 to that in 1979?
Your answer should be very brief. 0.97. What is the ratio of the Electricity production(% of total) of Natural gas sources in 1978 to that in 1979?
Provide a succinct answer. 0.95. What is the ratio of the Electricity production(% of total) in Oil sources in 1978 to that in 1979?
Give a very brief answer. 1.08. What is the ratio of the Electricity production(% of total) in Coal sources in 1978 to that in 1980?
Offer a terse response. 0.93. What is the ratio of the Electricity production(% of total) of Natural gas sources in 1978 to that in 1980?
Offer a very short reply. 0.94. What is the ratio of the Electricity production(% of total) in Oil sources in 1978 to that in 1980?
Provide a succinct answer. 1.2. What is the ratio of the Electricity production(% of total) in Coal sources in 1978 to that in 1981?
Provide a succinct answer. 0.92. What is the ratio of the Electricity production(% of total) of Natural gas sources in 1978 to that in 1981?
Give a very brief answer. 0.96. What is the ratio of the Electricity production(% of total) in Oil sources in 1978 to that in 1981?
Offer a very short reply. 1.31. What is the ratio of the Electricity production(% of total) in Coal sources in 1979 to that in 1980?
Your answer should be compact. 0.95. What is the ratio of the Electricity production(% of total) in Natural gas sources in 1979 to that in 1980?
Your answer should be compact. 0.99. What is the ratio of the Electricity production(% of total) of Oil sources in 1979 to that in 1980?
Your answer should be compact. 1.11. What is the ratio of the Electricity production(% of total) in Coal sources in 1979 to that in 1981?
Provide a succinct answer. 0.95. What is the ratio of the Electricity production(% of total) in Natural gas sources in 1979 to that in 1981?
Offer a terse response. 1.01. What is the ratio of the Electricity production(% of total) in Oil sources in 1979 to that in 1981?
Offer a very short reply. 1.21. What is the ratio of the Electricity production(% of total) of Natural gas sources in 1980 to that in 1981?
Your answer should be very brief. 1.03. What is the ratio of the Electricity production(% of total) of Oil sources in 1980 to that in 1981?
Provide a short and direct response. 1.09. What is the difference between the highest and the second highest Electricity production(% of total) in Coal sources?
Provide a succinct answer. 0.17. What is the difference between the highest and the second highest Electricity production(% of total) of Natural gas sources?
Provide a succinct answer. 0.07. What is the difference between the highest and the second highest Electricity production(% of total) in Oil sources?
Give a very brief answer. 1.33. What is the difference between the highest and the lowest Electricity production(% of total) of Coal sources?
Provide a succinct answer. 2.85. What is the difference between the highest and the lowest Electricity production(% of total) of Natural gas sources?
Offer a very short reply. 1.08. What is the difference between the highest and the lowest Electricity production(% of total) of Oil sources?
Give a very brief answer. 6.76. 